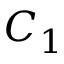<formula> <loc_0><loc_0><loc_500><loc_500>C _ { 1 }</formula> 